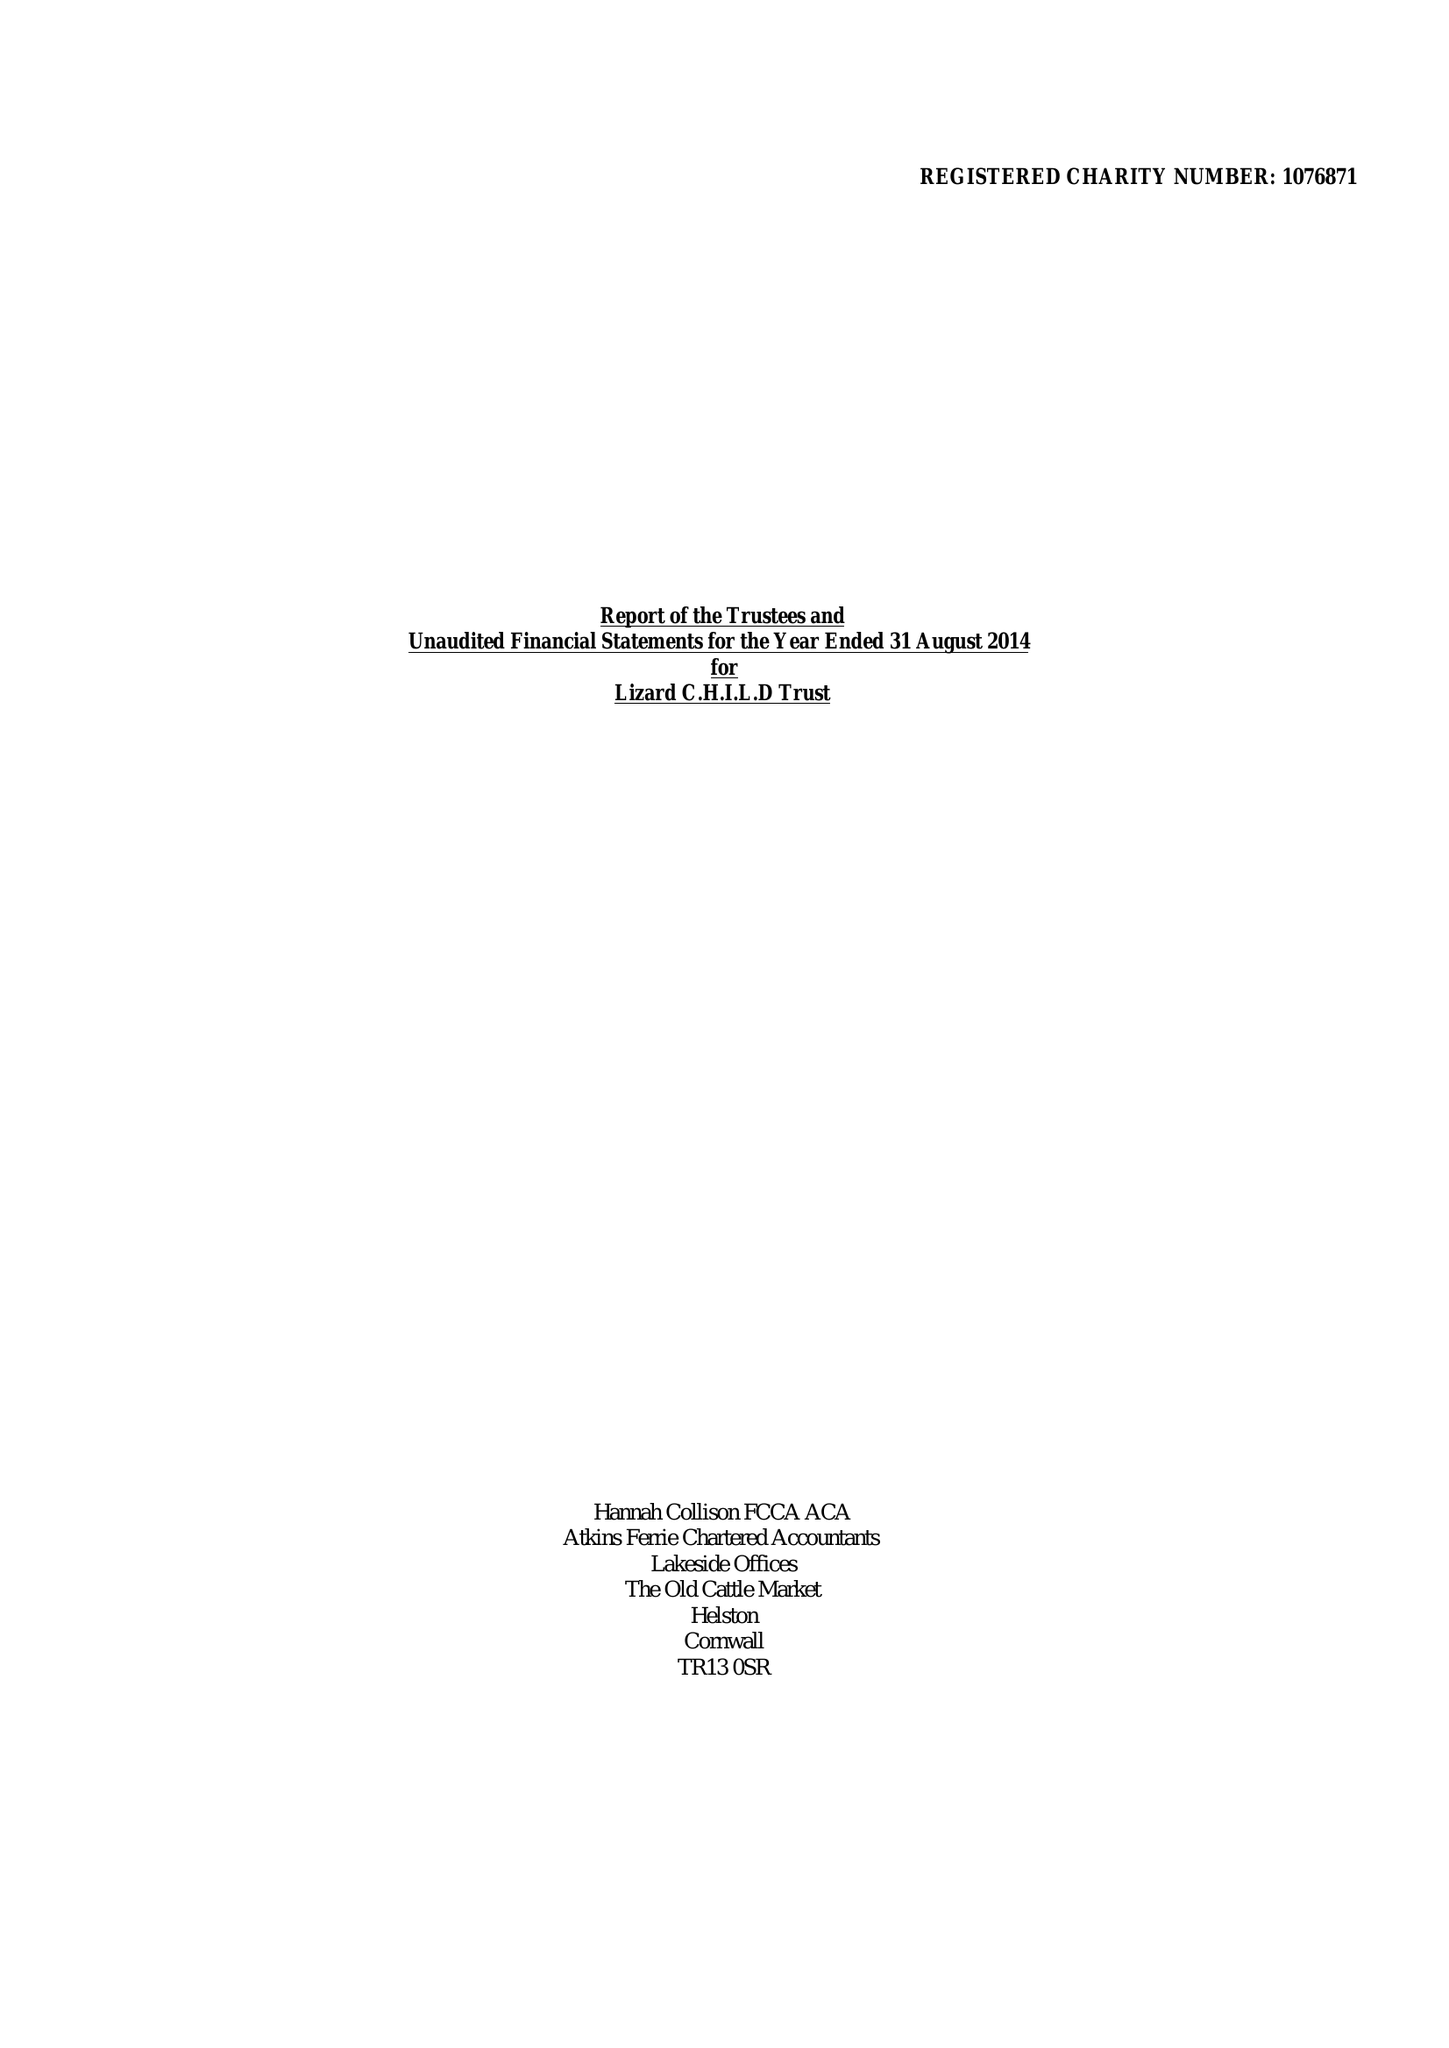What is the value for the address__post_town?
Answer the question using a single word or phrase. HELSTON 